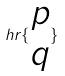<formula> <loc_0><loc_0><loc_500><loc_500>h r \{ \begin{matrix} p \\ q \end{matrix} \}</formula> 